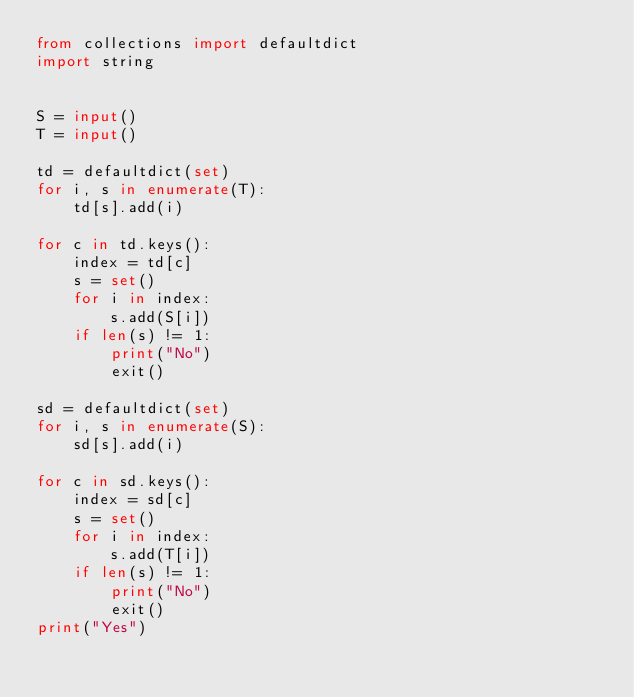Convert code to text. <code><loc_0><loc_0><loc_500><loc_500><_Python_>from collections import defaultdict
import string


S = input()
T = input()

td = defaultdict(set)
for i, s in enumerate(T):
    td[s].add(i)

for c in td.keys():
    index = td[c]
    s = set()
    for i in index:
        s.add(S[i])
    if len(s) != 1:
        print("No")
        exit()

sd = defaultdict(set)
for i, s in enumerate(S):
    sd[s].add(i)

for c in sd.keys():
    index = sd[c]
    s = set()
    for i in index:
        s.add(T[i])
    if len(s) != 1:
        print("No")
        exit()
print("Yes")
</code> 